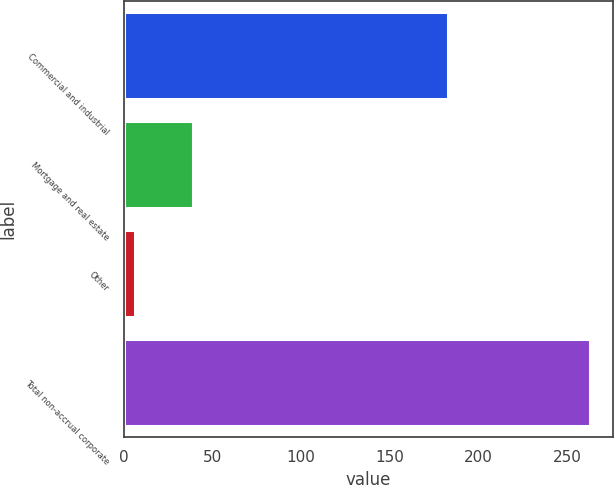<chart> <loc_0><loc_0><loc_500><loc_500><bar_chart><fcel>Commercial and industrial<fcel>Mortgage and real estate<fcel>Other<fcel>Total non-accrual corporate<nl><fcel>183<fcel>39<fcel>6<fcel>263<nl></chart> 